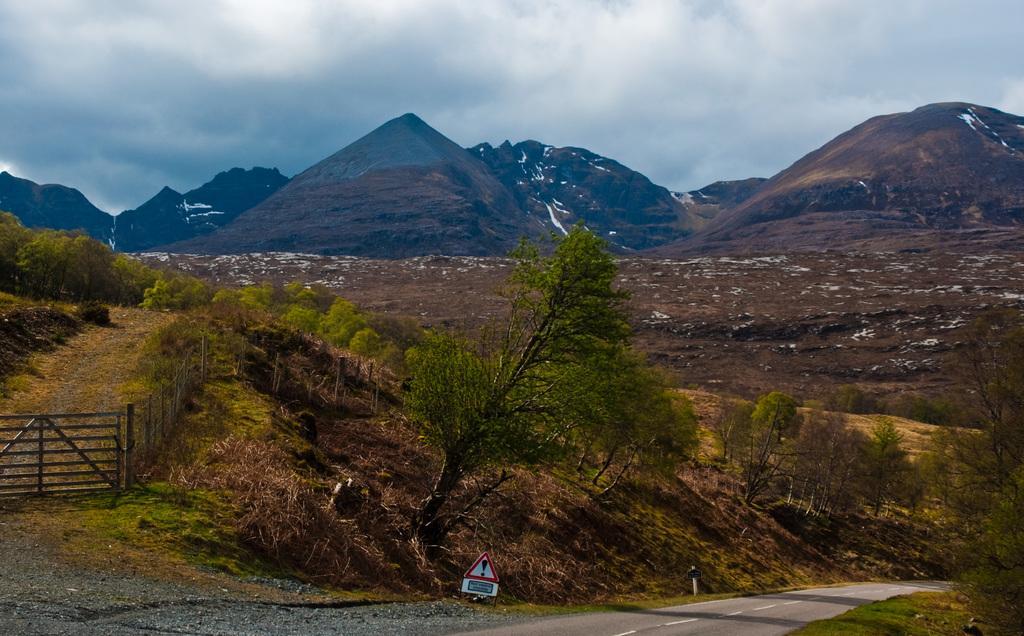Can you describe this image briefly? In this image, we can see a fence, poles, trees and there is a board. In the background, there are hills and some part is covered with snow. At the bottom, there is a road and at the top, there is sky. 